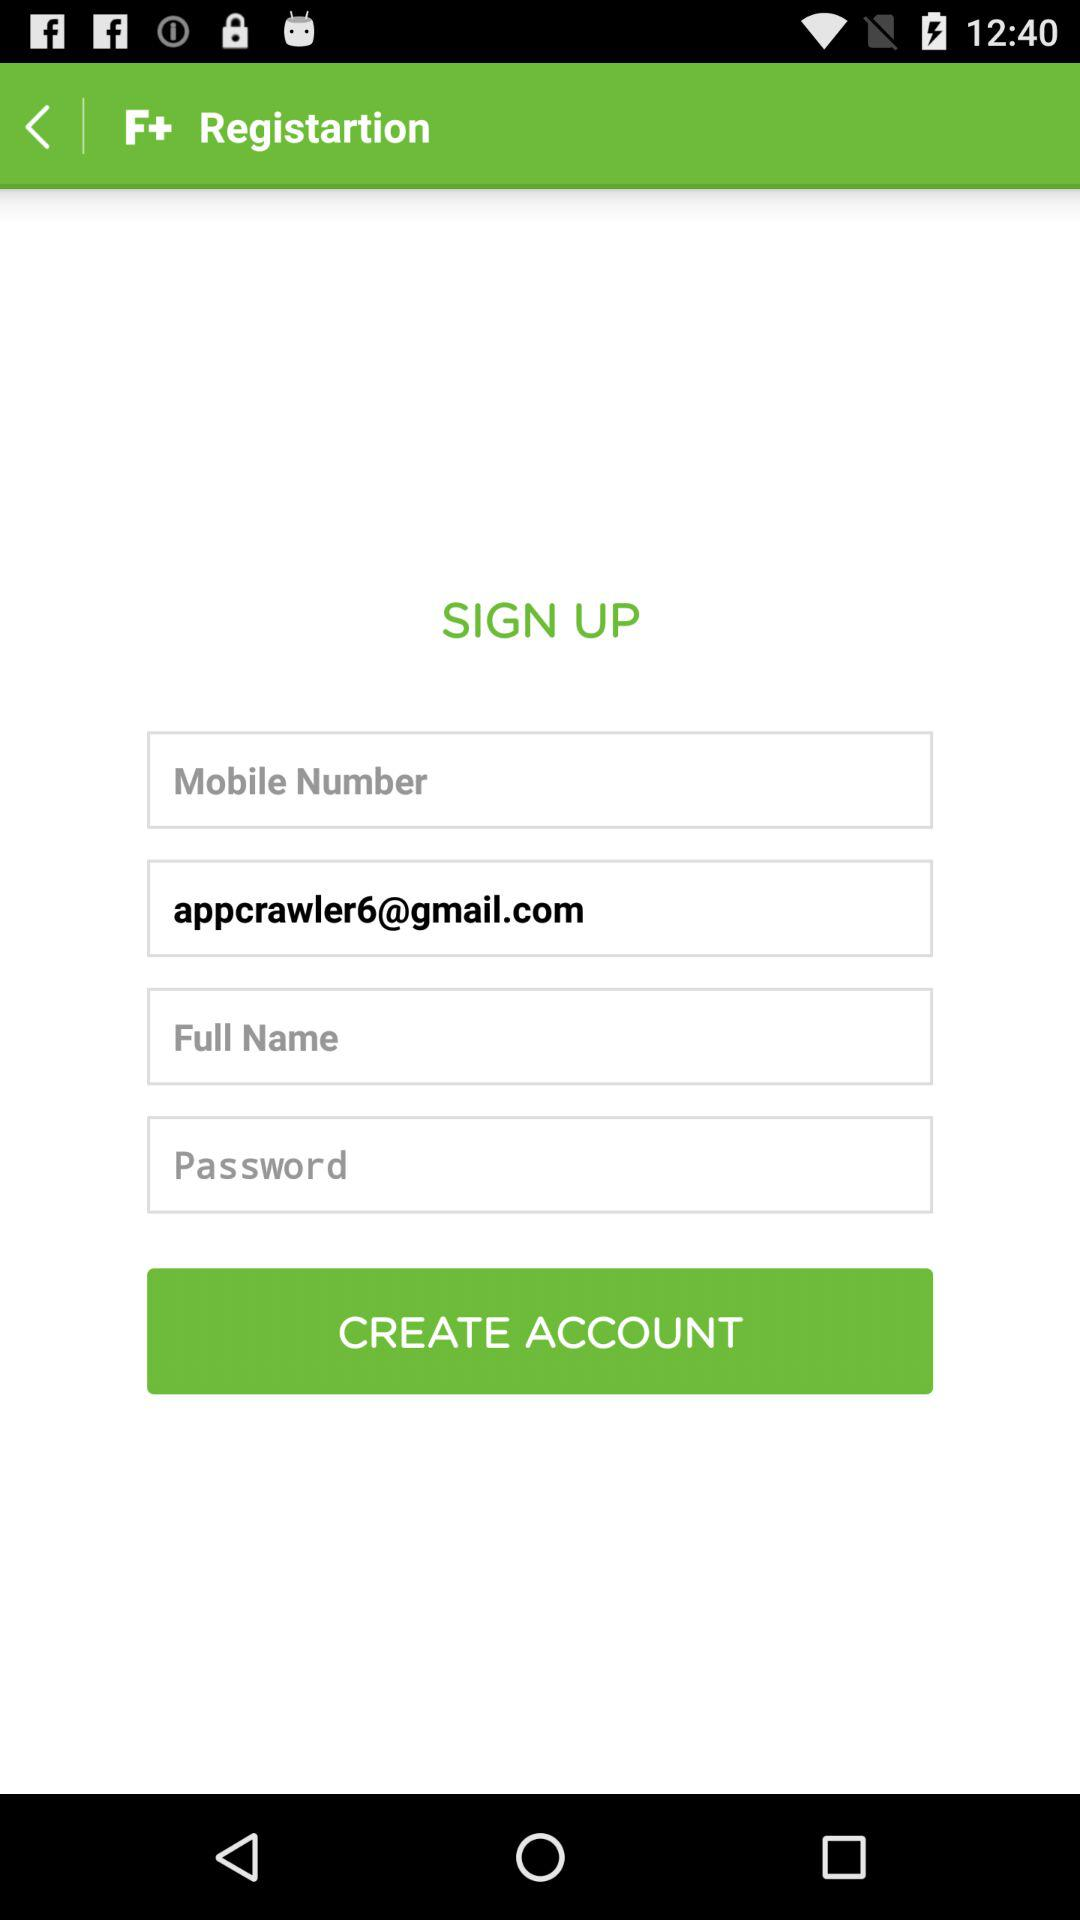To whom does the email address belong?
When the provided information is insufficient, respond with <no answer>. <no answer> 